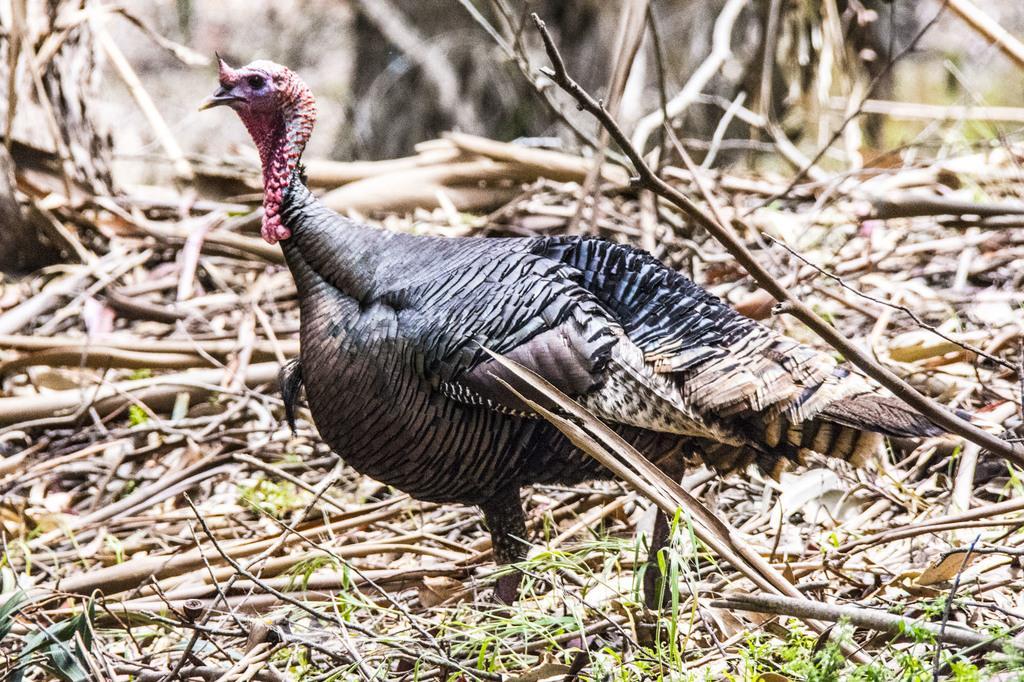Can you describe this image briefly? Background portion of the picture is blur. On the ground we can see the twigs, green grass and this picture is mainly highlighted with a turkey bird. 